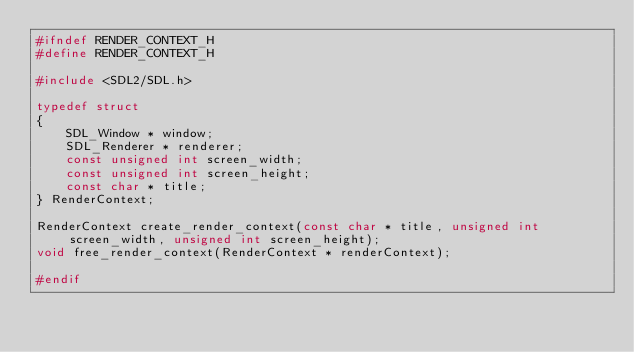<code> <loc_0><loc_0><loc_500><loc_500><_C_>#ifndef RENDER_CONTEXT_H
#define RENDER_CONTEXT_H

#include <SDL2/SDL.h>

typedef struct
{
    SDL_Window * window;
    SDL_Renderer * renderer;
    const unsigned int screen_width;
    const unsigned int screen_height;
    const char * title;
} RenderContext;

RenderContext create_render_context(const char * title, unsigned int screen_width, unsigned int screen_height);
void free_render_context(RenderContext * renderContext);

#endif</code> 